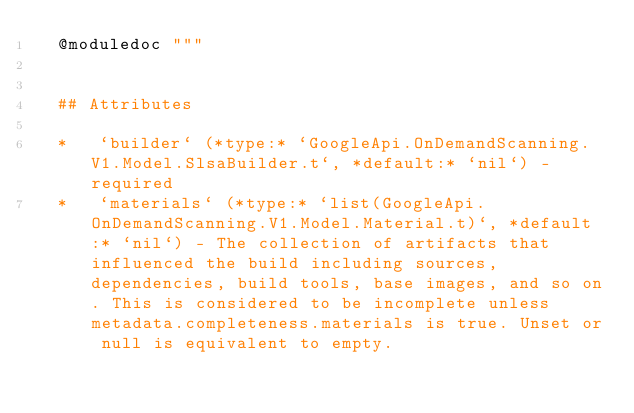<code> <loc_0><loc_0><loc_500><loc_500><_Elixir_>  @moduledoc """


  ## Attributes

  *   `builder` (*type:* `GoogleApi.OnDemandScanning.V1.Model.SlsaBuilder.t`, *default:* `nil`) - required
  *   `materials` (*type:* `list(GoogleApi.OnDemandScanning.V1.Model.Material.t)`, *default:* `nil`) - The collection of artifacts that influenced the build including sources, dependencies, build tools, base images, and so on. This is considered to be incomplete unless metadata.completeness.materials is true. Unset or null is equivalent to empty.</code> 